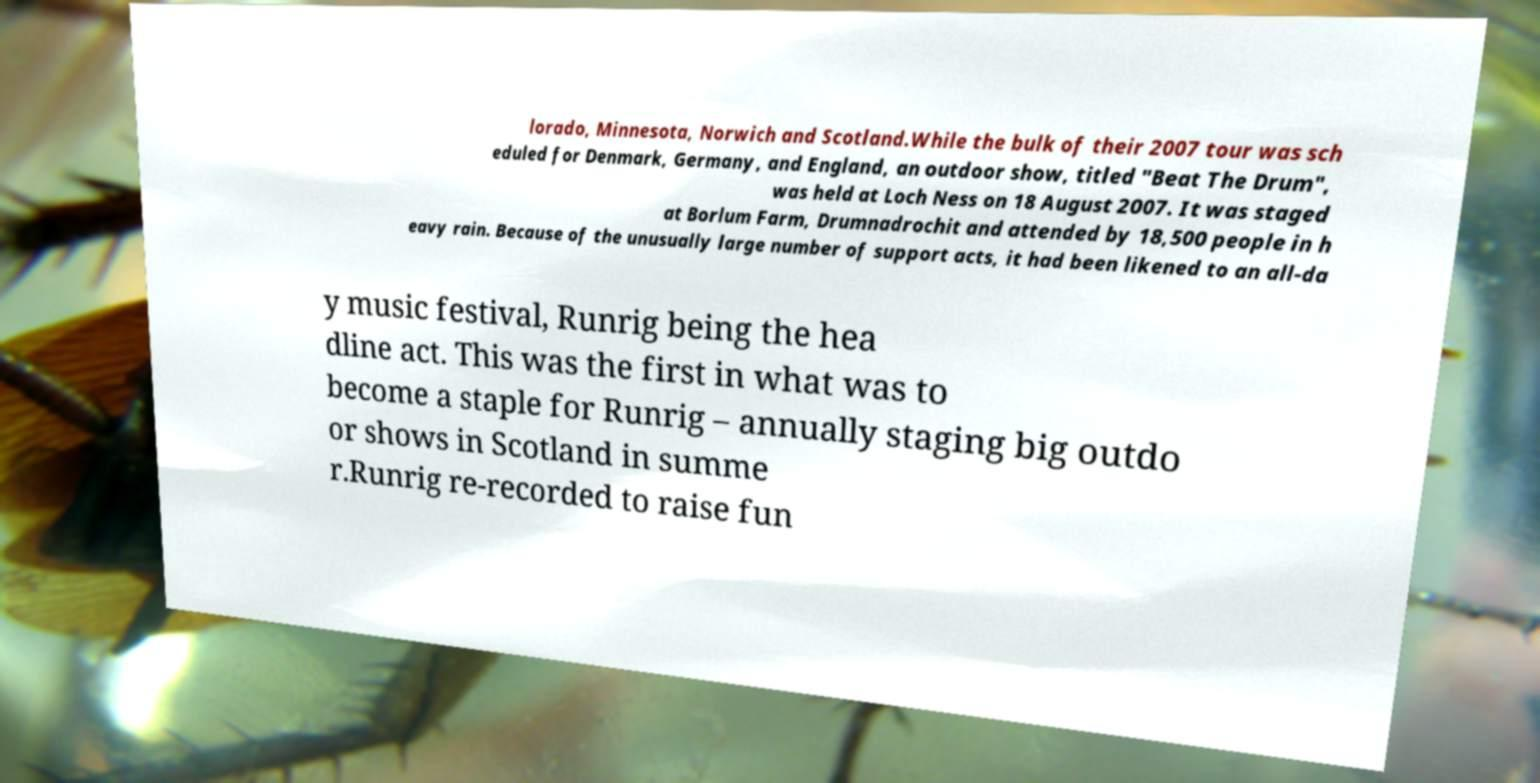Could you assist in decoding the text presented in this image and type it out clearly? lorado, Minnesota, Norwich and Scotland.While the bulk of their 2007 tour was sch eduled for Denmark, Germany, and England, an outdoor show, titled "Beat The Drum", was held at Loch Ness on 18 August 2007. It was staged at Borlum Farm, Drumnadrochit and attended by 18,500 people in h eavy rain. Because of the unusually large number of support acts, it had been likened to an all-da y music festival, Runrig being the hea dline act. This was the first in what was to become a staple for Runrig – annually staging big outdo or shows in Scotland in summe r.Runrig re-recorded to raise fun 